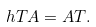Convert formula to latex. <formula><loc_0><loc_0><loc_500><loc_500>\ h T A = A T .</formula> 